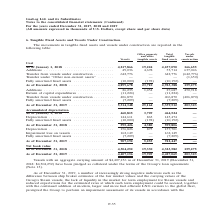From Gaslog's financial document, In which years was the movements in tangible fixed assets and vessels under construction recorded for? The document shows two values: 2018 and 2019. From the document: "As of December 31, 2019 . 5,314,348 25,164 5,339,512 203,323 Cost As of January 1, 2018 . 4,217,866 19,224 4,237,090 166,655 Additions . 49,036 4,678 ..." Also, Why did the Group perform impairment assessment of its vessels? Increasingly strong negative indicators such as the difference between ship broker estimates of the fair market values and the carrying values of the Group’s Steam vessels, the lack of liquidity in the market for term employment for Steam vessels and reduced expectations for the estimated rates at which such term employment could be secured, together with the continued addition of modern, larger and more fuel efficient LNG carriers to the global fleet. The document states: "As of December 31, 2019, a number of increasingly strong negative indicators such as the difference between ship broker estimates of the fair market v..." Also, What was the aggregate carrying amount of the vessels in 2018? According to the financial document, $4,304,252 (in thousands). The relevant text states: "07,156 as of December 31, 2019 (December 31, 2018: $4,304,252) have been pledged as collateral under the terms of the Group’s loan agreements (Note 13)...." Additionally, In which end year has a higher vessel accumulated depreciation? According to the financial document, 2019. The relevant text states: "As of December 31, 2019 . 5,314,348 25,164 5,339,512 203,323..." Also, can you calculate: What was the change in vessel cost from end 2018 to end 2019? Based on the calculation: 5,314,348 - 4,899,678 , the result is 414670. This is based on the information: "As of December 31, 2018 . 4,899,678 23,710 4,923,388 159,275 As of December 31, 2019 . 5,314,348 25,164 5,339,512 203,323..." The key data points involved are: 4,899,678, 5,314,348. Also, can you calculate: What was the percentage change in vessel net book value end 2018 to end 2019? To answer this question, I need to perform calculations using the financial data. The calculation is: (4,407,156 - 4,304,252)/4,304,252 , which equals 2.39 (percentage). This is based on the information: "Net book value As of December 31, 2018 . 4,304,252 19,330 4,323,582 159,275 As of December 31, 2019 . 4,407,156 19,909 4,427,065 203,323..." The key data points involved are: 4,304,252, 4,407,156. 